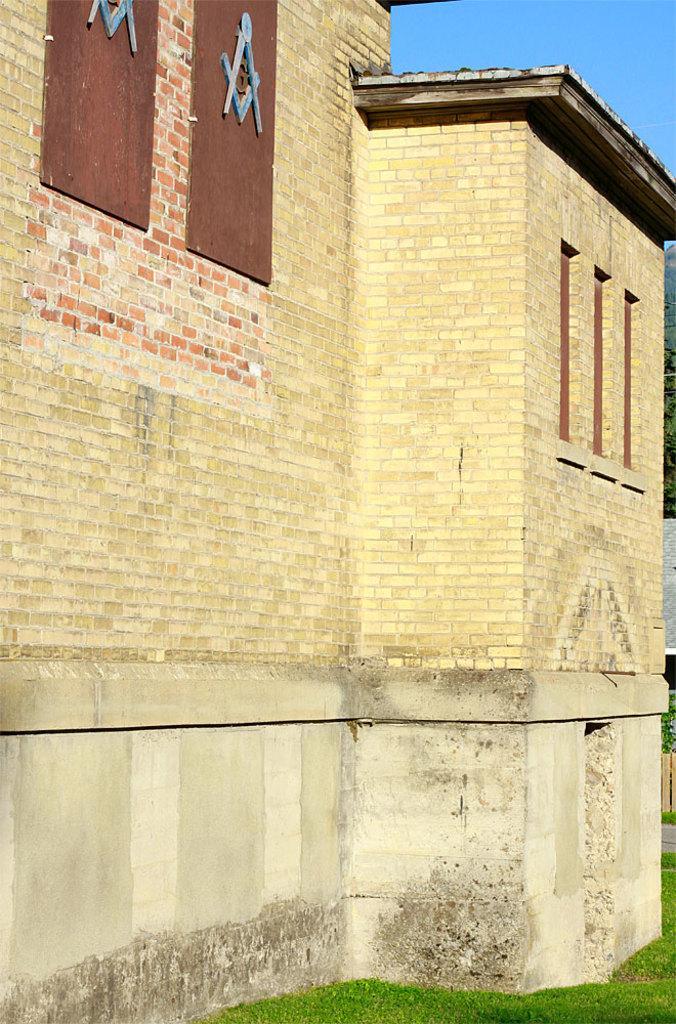Please provide a concise description of this image. In this image we can see a building with windows. We can also see some grass and the sky. 